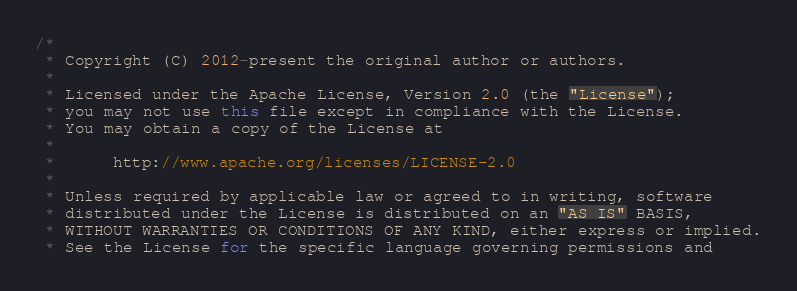<code> <loc_0><loc_0><loc_500><loc_500><_Java_>/*
 * Copyright (C) 2012-present the original author or authors.
 *
 * Licensed under the Apache License, Version 2.0 (the "License");
 * you may not use this file except in compliance with the License.
 * You may obtain a copy of the License at
 *
 *      http://www.apache.org/licenses/LICENSE-2.0
 *
 * Unless required by applicable law or agreed to in writing, software
 * distributed under the License is distributed on an "AS IS" BASIS,
 * WITHOUT WARRANTIES OR CONDITIONS OF ANY KIND, either express or implied.
 * See the License for the specific language governing permissions and</code> 